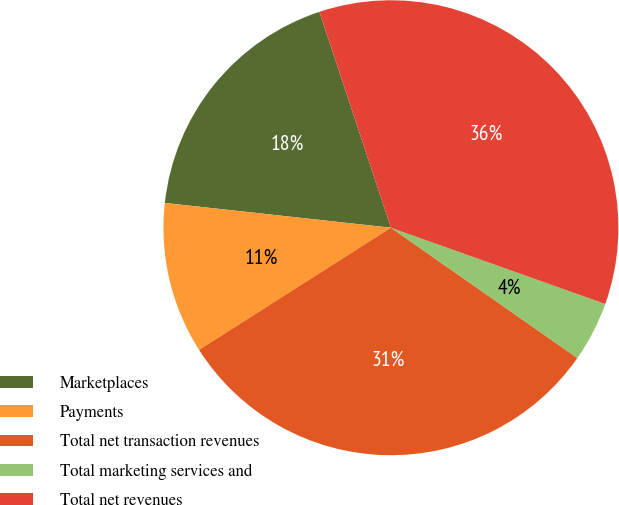Convert chart to OTSL. <chart><loc_0><loc_0><loc_500><loc_500><pie_chart><fcel>Marketplaces<fcel>Payments<fcel>Total net transaction revenues<fcel>Total marketing services and<fcel>Total net revenues<nl><fcel>18.17%<fcel>10.76%<fcel>31.27%<fcel>4.27%<fcel>35.54%<nl></chart> 